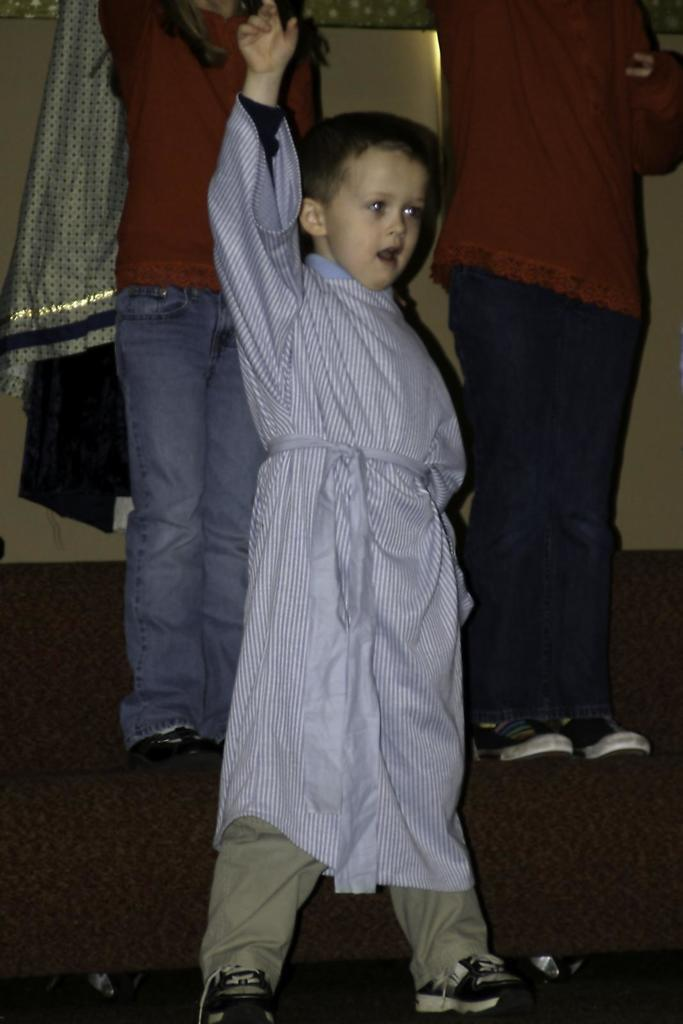Who is the main subject in the front of the image? There is a boy standing in the front of the image. Can you describe the people in the background of the image? Both of the persons in the background are wearing red-colored dresses. What type of brick is being used to build the giraffe in the image? There is no giraffe or brick present in the image. 